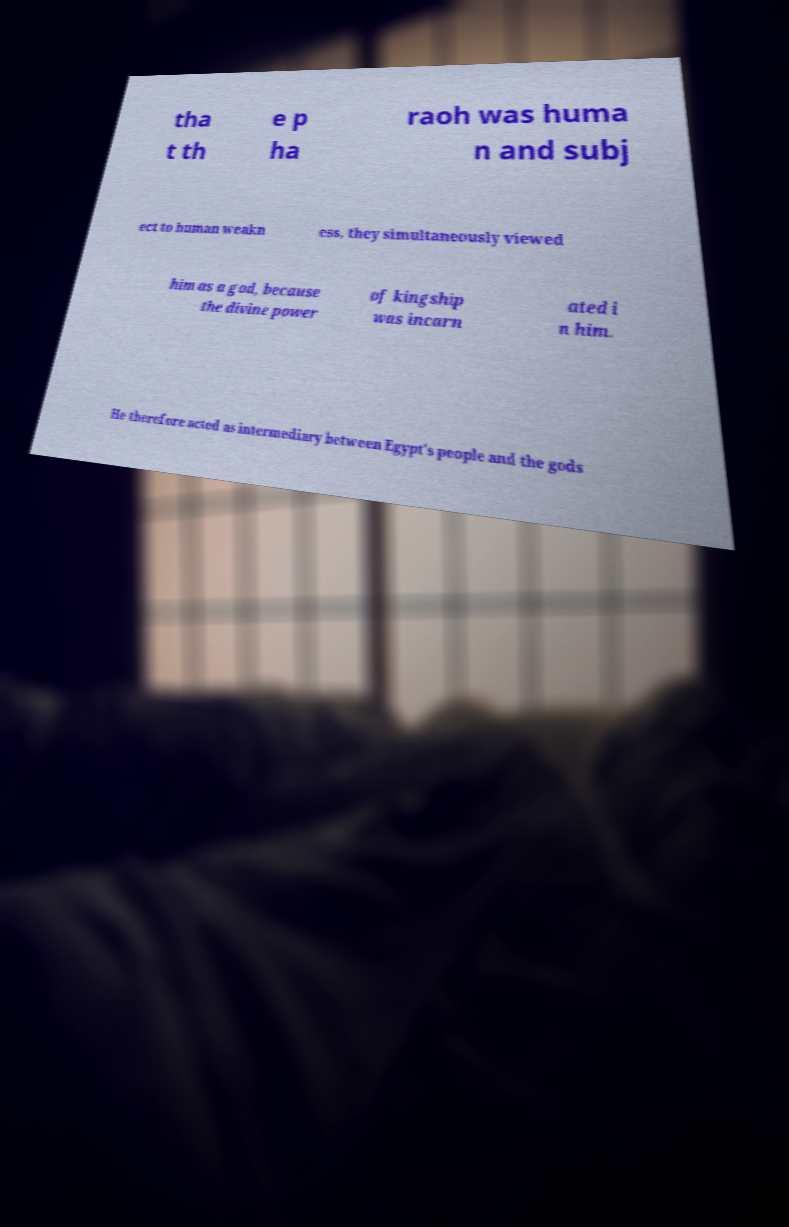Could you extract and type out the text from this image? tha t th e p ha raoh was huma n and subj ect to human weakn ess, they simultaneously viewed him as a god, because the divine power of kingship was incarn ated i n him. He therefore acted as intermediary between Egypt's people and the gods 